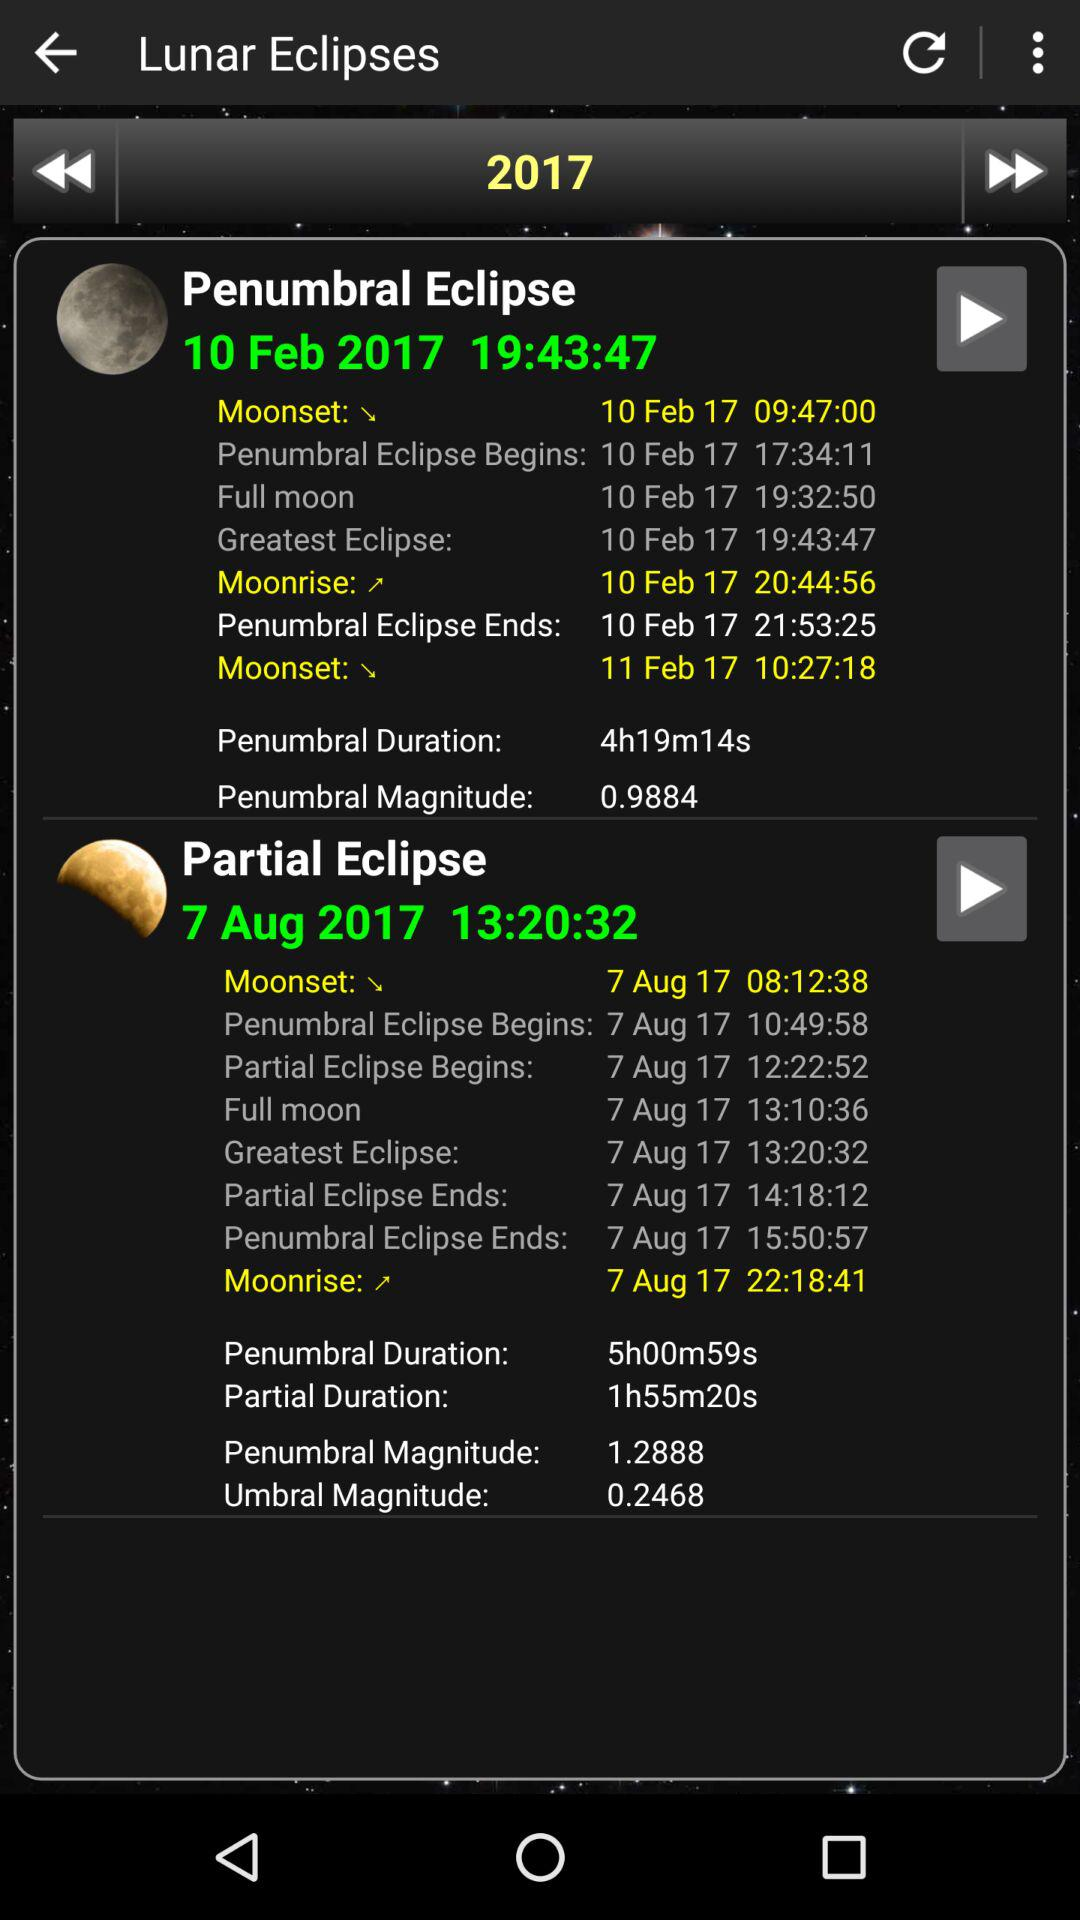Which year is selected? The selected year is 2017. 